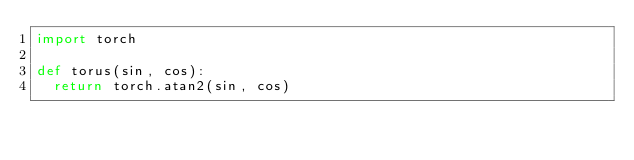Convert code to text. <code><loc_0><loc_0><loc_500><loc_500><_Python_>import torch

def torus(sin, cos):
  return torch.atan2(sin, cos)
</code> 